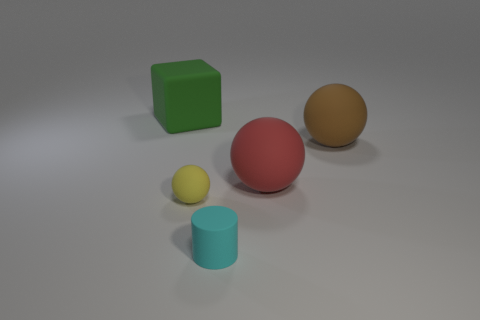Are there fewer big green matte things than big gray shiny things?
Give a very brief answer. No. There is a big rubber thing in front of the big brown thing; does it have the same shape as the yellow object in front of the big brown rubber thing?
Offer a very short reply. Yes. How many things are gray rubber balls or tiny cyan things?
Keep it short and to the point. 1. There is a sphere that is the same size as the red rubber thing; what color is it?
Your answer should be compact. Brown. How many large cubes are behind the object that is in front of the small yellow rubber object?
Keep it short and to the point. 1. How many matte objects are on the right side of the big green rubber thing and behind the big red matte sphere?
Make the answer very short. 1. What number of things are either big spheres that are behind the red rubber thing or rubber objects to the left of the tiny yellow object?
Your answer should be very brief. 2. How many other objects are there of the same size as the brown matte sphere?
Give a very brief answer. 2. There is a matte object in front of the tiny thing to the left of the small rubber cylinder; what is its shape?
Keep it short and to the point. Cylinder. What is the color of the small matte ball?
Offer a terse response. Yellow. 